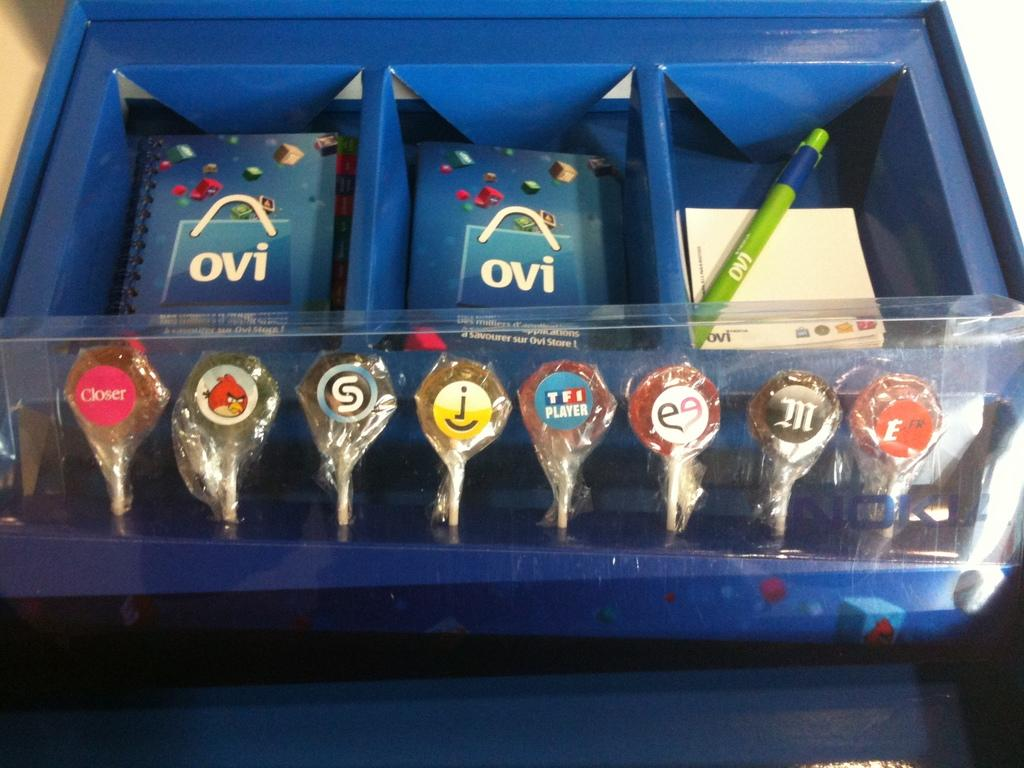<image>
Share a concise interpretation of the image provided. A series of lollipops are displayed in front of two pouches that say Ovi. 